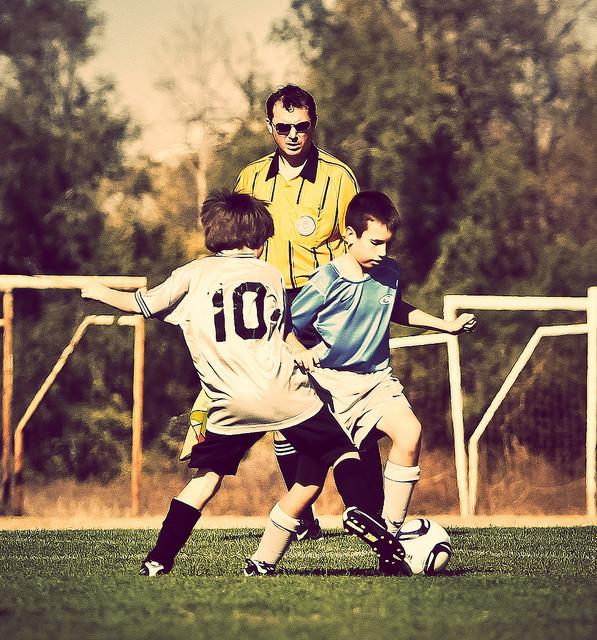Do you see an adult coaching the kids?
Concise answer only. Yes. What number is visible?
Write a very short answer. 10. Are the boys kicking each other?
Keep it brief. No. 